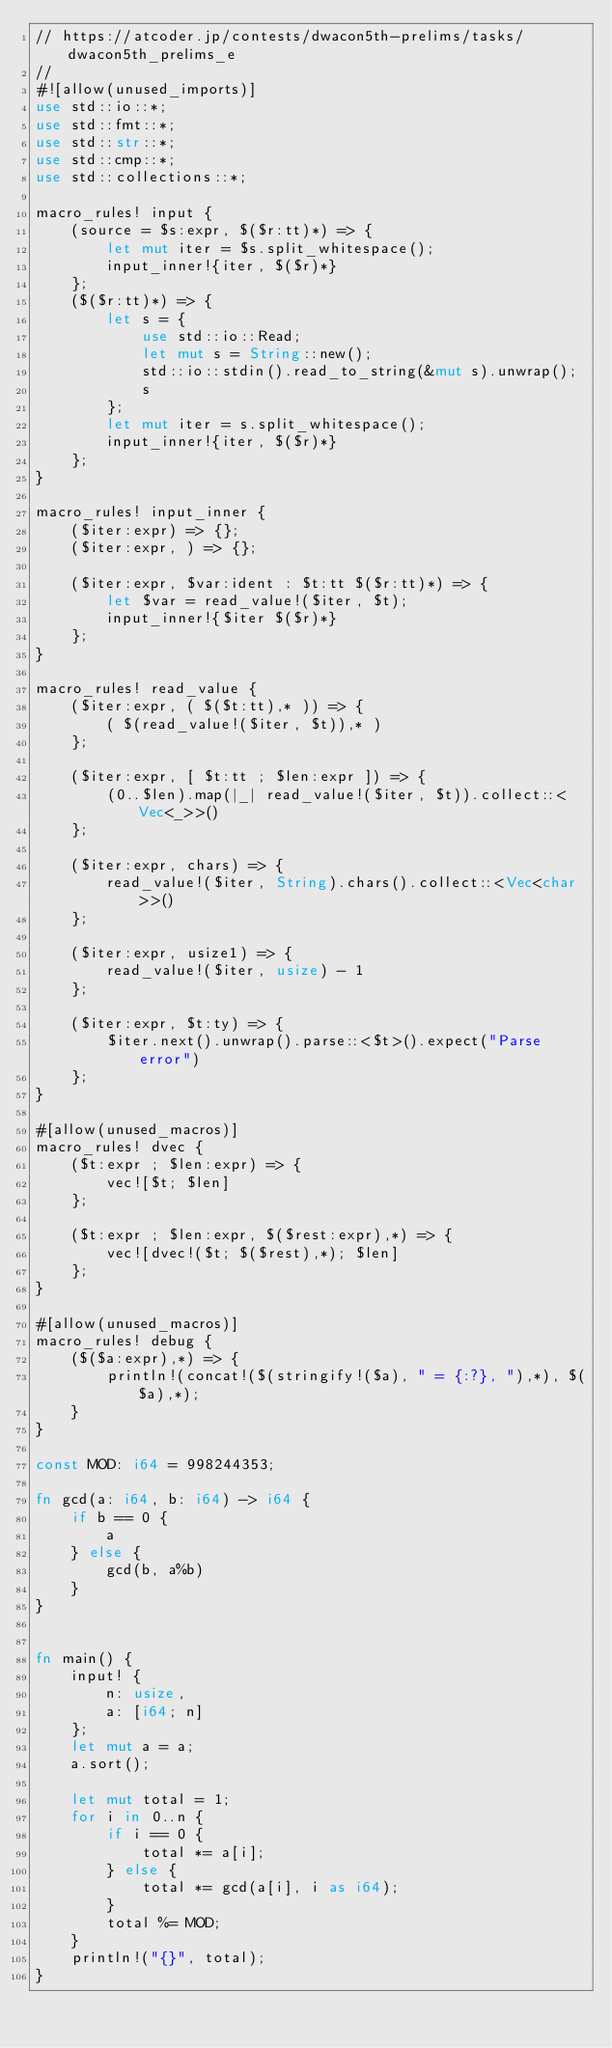Convert code to text. <code><loc_0><loc_0><loc_500><loc_500><_Rust_>// https://atcoder.jp/contests/dwacon5th-prelims/tasks/dwacon5th_prelims_e
//
#![allow(unused_imports)]
use std::io::*;
use std::fmt::*;
use std::str::*;
use std::cmp::*;
use std::collections::*;

macro_rules! input {
    (source = $s:expr, $($r:tt)*) => {
        let mut iter = $s.split_whitespace();
        input_inner!{iter, $($r)*}
    };
    ($($r:tt)*) => {
        let s = {
            use std::io::Read;
            let mut s = String::new();
            std::io::stdin().read_to_string(&mut s).unwrap();
            s
        };
        let mut iter = s.split_whitespace();
        input_inner!{iter, $($r)*}
    };
}

macro_rules! input_inner {
    ($iter:expr) => {};
    ($iter:expr, ) => {};

    ($iter:expr, $var:ident : $t:tt $($r:tt)*) => {
        let $var = read_value!($iter, $t);
        input_inner!{$iter $($r)*}
    };
}

macro_rules! read_value {
    ($iter:expr, ( $($t:tt),* )) => {
        ( $(read_value!($iter, $t)),* )
    };

    ($iter:expr, [ $t:tt ; $len:expr ]) => {
        (0..$len).map(|_| read_value!($iter, $t)).collect::<Vec<_>>()
    };

    ($iter:expr, chars) => {
        read_value!($iter, String).chars().collect::<Vec<char>>()
    };

    ($iter:expr, usize1) => {
        read_value!($iter, usize) - 1
    };

    ($iter:expr, $t:ty) => {
        $iter.next().unwrap().parse::<$t>().expect("Parse error")
    };
}

#[allow(unused_macros)]
macro_rules! dvec {
    ($t:expr ; $len:expr) => {
        vec![$t; $len]
    };

    ($t:expr ; $len:expr, $($rest:expr),*) => {
        vec![dvec!($t; $($rest),*); $len]
    };
}

#[allow(unused_macros)]
macro_rules! debug {
    ($($a:expr),*) => {
        println!(concat!($(stringify!($a), " = {:?}, "),*), $($a),*);
    }
}

const MOD: i64 = 998244353;

fn gcd(a: i64, b: i64) -> i64 {
    if b == 0 {
        a
    } else {
        gcd(b, a%b)
    }
}


fn main() {
    input! {
        n: usize,
        a: [i64; n]
    };
    let mut a = a;
    a.sort();

    let mut total = 1;
    for i in 0..n {
        if i == 0 {
            total *= a[i];
        } else {
            total *= gcd(a[i], i as i64);
        }
        total %= MOD;
    }
    println!("{}", total);
}
</code> 